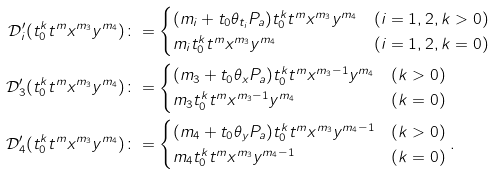Convert formula to latex. <formula><loc_0><loc_0><loc_500><loc_500>\mathcal { D } ^ { \prime } _ { i } ( t _ { 0 } ^ { k } t ^ { m } x ^ { m _ { 3 } } y ^ { m _ { 4 } } ) & \colon = \begin{cases} ( m _ { i } + t _ { 0 } \theta _ { t _ { i } } P _ { a } ) t _ { 0 } ^ { k } t ^ { m } x ^ { m _ { 3 } } y ^ { m _ { 4 } } & ( i = 1 , 2 , k > 0 ) \\ m _ { i } t _ { 0 } ^ { k } t ^ { m } x ^ { m _ { 3 } } y ^ { m _ { 4 } } & ( i = 1 , 2 , k = 0 ) \end{cases} \\ \mathcal { D } ^ { \prime } _ { 3 } ( t _ { 0 } ^ { k } t ^ { m } x ^ { m _ { 3 } } y ^ { m _ { 4 } } ) & \colon = \begin{cases} ( m _ { 3 } + t _ { 0 } \theta _ { x } P _ { a } ) t _ { 0 } ^ { k } t ^ { m } x ^ { m _ { 3 } - 1 } y ^ { m _ { 4 } } & ( k > 0 ) \\ m _ { 3 } t _ { 0 } ^ { k } t ^ { m } x ^ { m _ { 3 } - 1 } y ^ { m _ { 4 } } & ( k = 0 ) \end{cases} \\ \mathcal { D } ^ { \prime } _ { 4 } ( t _ { 0 } ^ { k } t ^ { m } x ^ { m _ { 3 } } y ^ { m _ { 4 } } ) & \colon = \begin{cases} ( m _ { 4 } + t _ { 0 } \theta _ { y } P _ { a } ) t _ { 0 } ^ { k } t ^ { m } x ^ { m _ { 3 } } y ^ { m _ { 4 } - 1 } & ( k > 0 ) \\ m _ { 4 } t _ { 0 } ^ { k } t ^ { m } x ^ { m _ { 3 } } y ^ { m _ { 4 } - 1 } & ( k = 0 ) \end{cases} .</formula> 